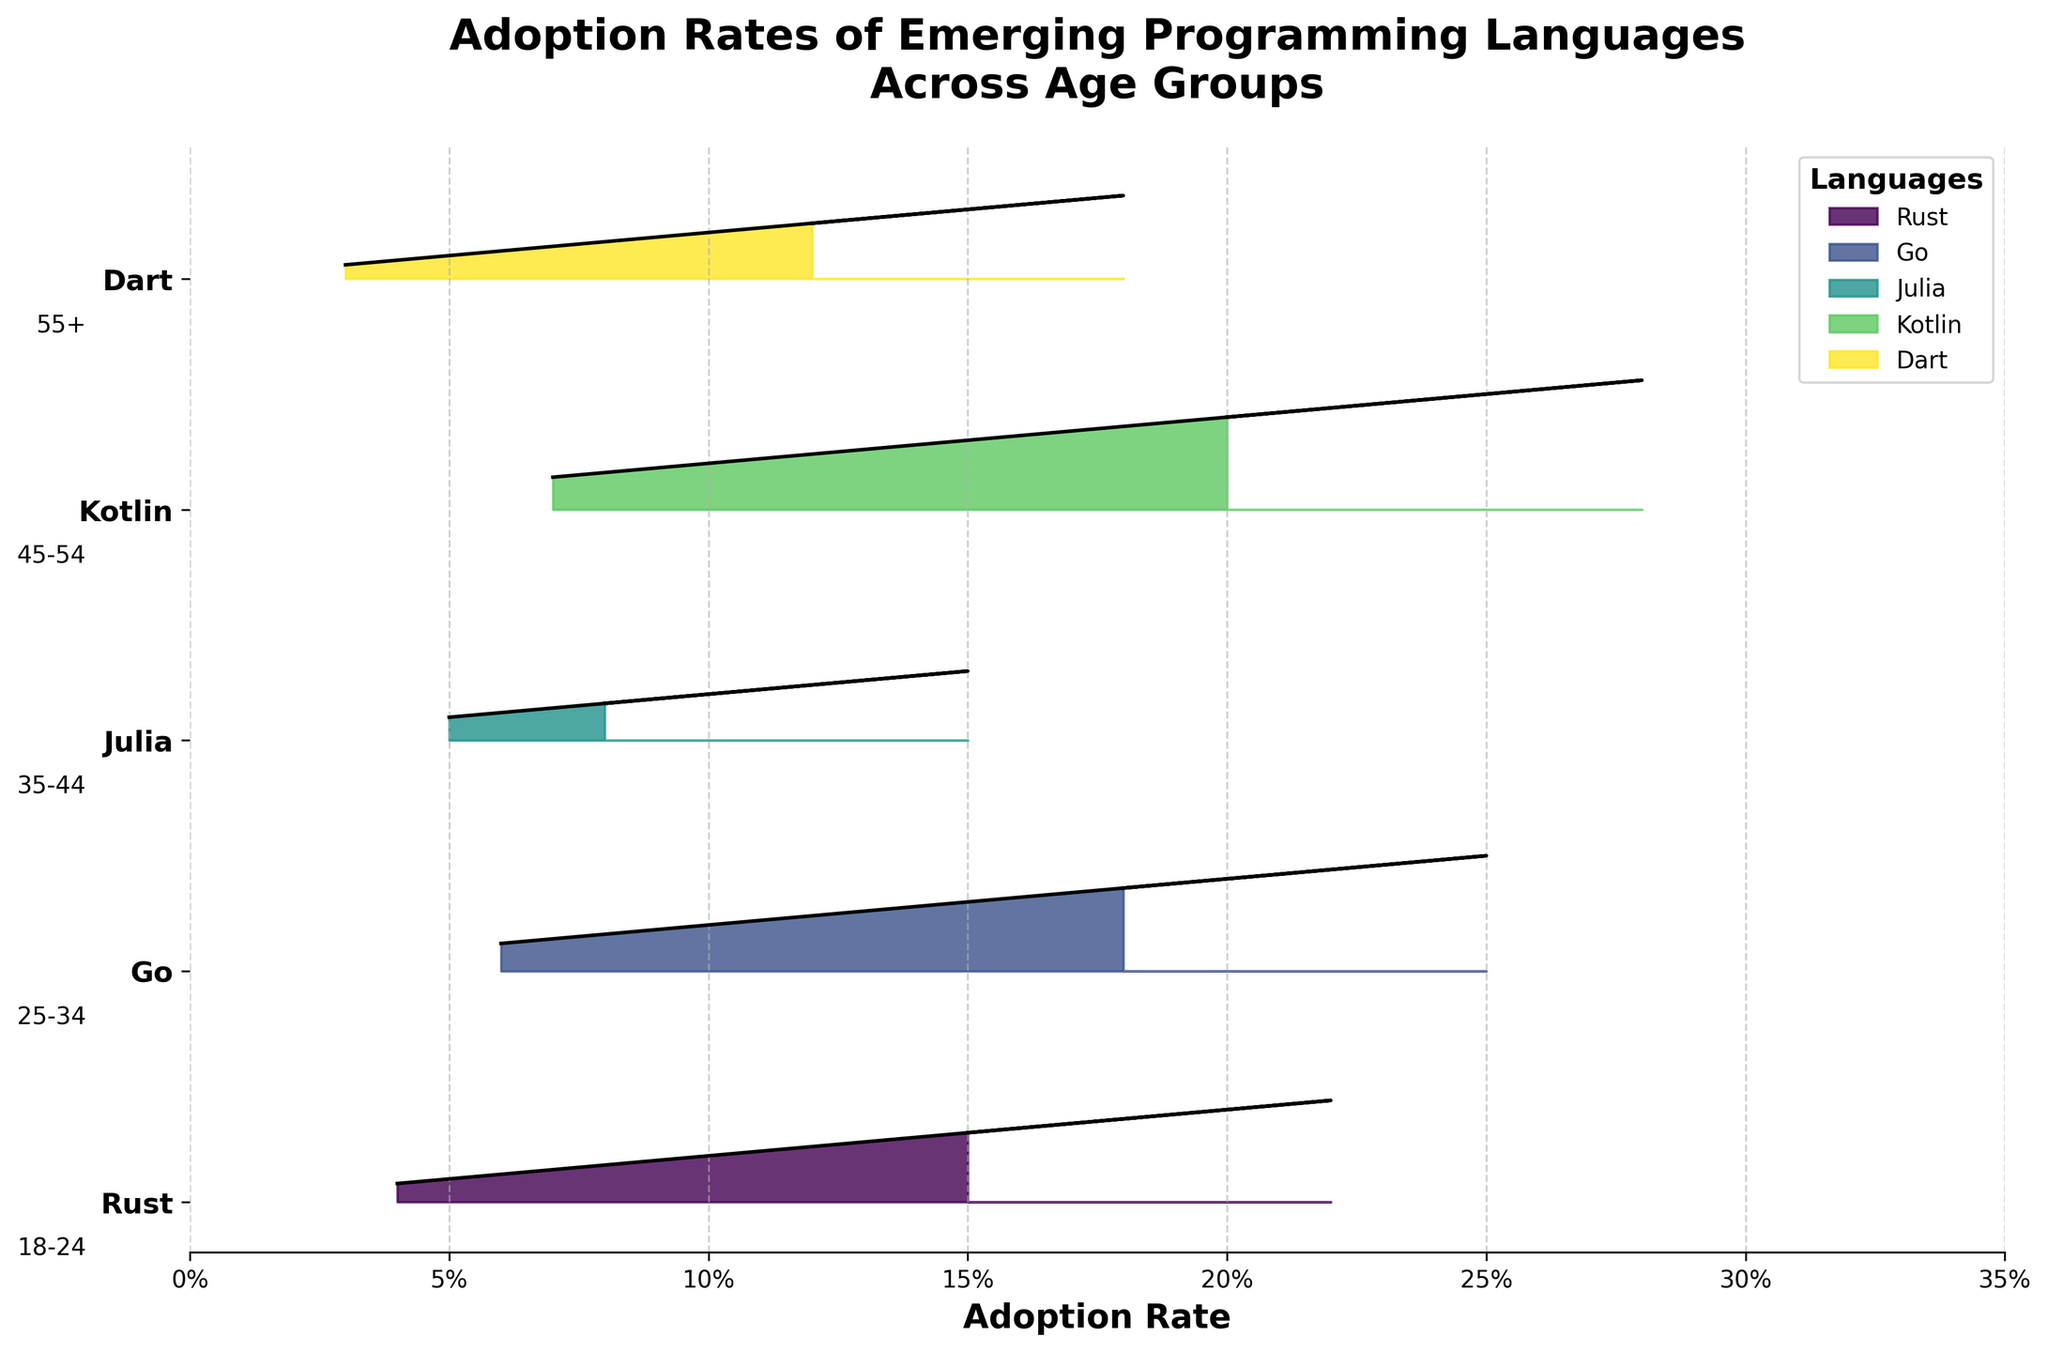What is the title of the figure? The title of the figure is usually placed at the top, and it provides an overview of what the figure represents. In this case, it states the purpose of the figure regarding the adoption rates of programming languages across age groups.
Answer: Adoption Rates of Emerging Programming Languages Across Age Groups What is the highest adoption rate for Kotlin among different age groups? To determine this, find the peak value of Kotlin's adoption rates among the displayed age groups. By visually examining the plot, you can spot where Kotlin’s adoption rate reaches its maximum.
Answer: 0.28 Which age group has the lowest adoption rate for Rust? By inspecting the plot and identifying which segment of Rust has the smallest value, we can determine the age group with the lowest adoption rate. This requires noting the smallest value associated with Rust.
Answer: 55+ Compare the adoption rates of Go and Dart in the 25-34 age group. Which is higher? Find the lines or shaded areas representing Go and Dart in the 25-34 age group. Compare their heights or locations to determine which one has a greater value.
Answer: Go For the 18-24 age group, which language has the highest adoption rate? Look for the tallest peak within the 18-24 age group among all the languages. Identify which language corresponds to that peak.
Answer: Kotlin What is the average adoption rate of Julia across all age groups? Sum the adoption rates for Julia across all age groups and divide by the number of age groups to get the average. The calculation should be (0.08 + 0.12 + 0.15 + 0.10 + 0.05) / 5.
Answer: 0.10 How does the adoption rate of Dart for the 45-54 age group compare to Rust for the same age group? Look at the respective heights of the adoption rates for Dart and Rust within the 45-54 age group. Determine if one is greater, less, or if they are equal.
Answer: Dart is higher Which language shows a consistent decline in adoption rate as the age group increases? Inspect each language's pattern across the age groups to check for a consistent decrease from the youngest to the oldest age group.
Answer: Rust In the 18-24 age group, which language has the lowest adoption rate? Identify the shortest peak among all the languages within the 18-24 age group by visually inspecting the plot.
Answer: Julia 